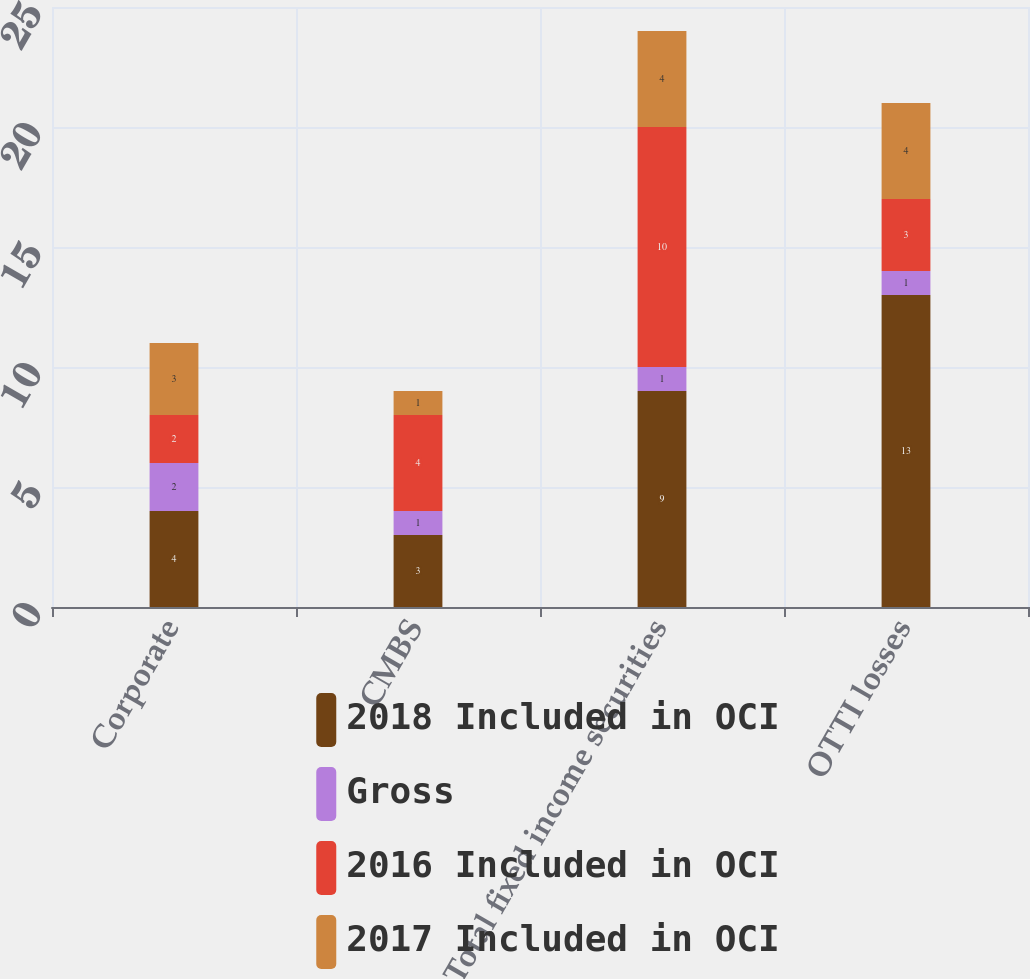Convert chart to OTSL. <chart><loc_0><loc_0><loc_500><loc_500><stacked_bar_chart><ecel><fcel>Corporate<fcel>CMBS<fcel>Total fixed income securities<fcel>OTTI losses<nl><fcel>2018 Included in OCI<fcel>4<fcel>3<fcel>9<fcel>13<nl><fcel>Gross<fcel>2<fcel>1<fcel>1<fcel>1<nl><fcel>2016 Included in OCI<fcel>2<fcel>4<fcel>10<fcel>3<nl><fcel>2017 Included in OCI<fcel>3<fcel>1<fcel>4<fcel>4<nl></chart> 